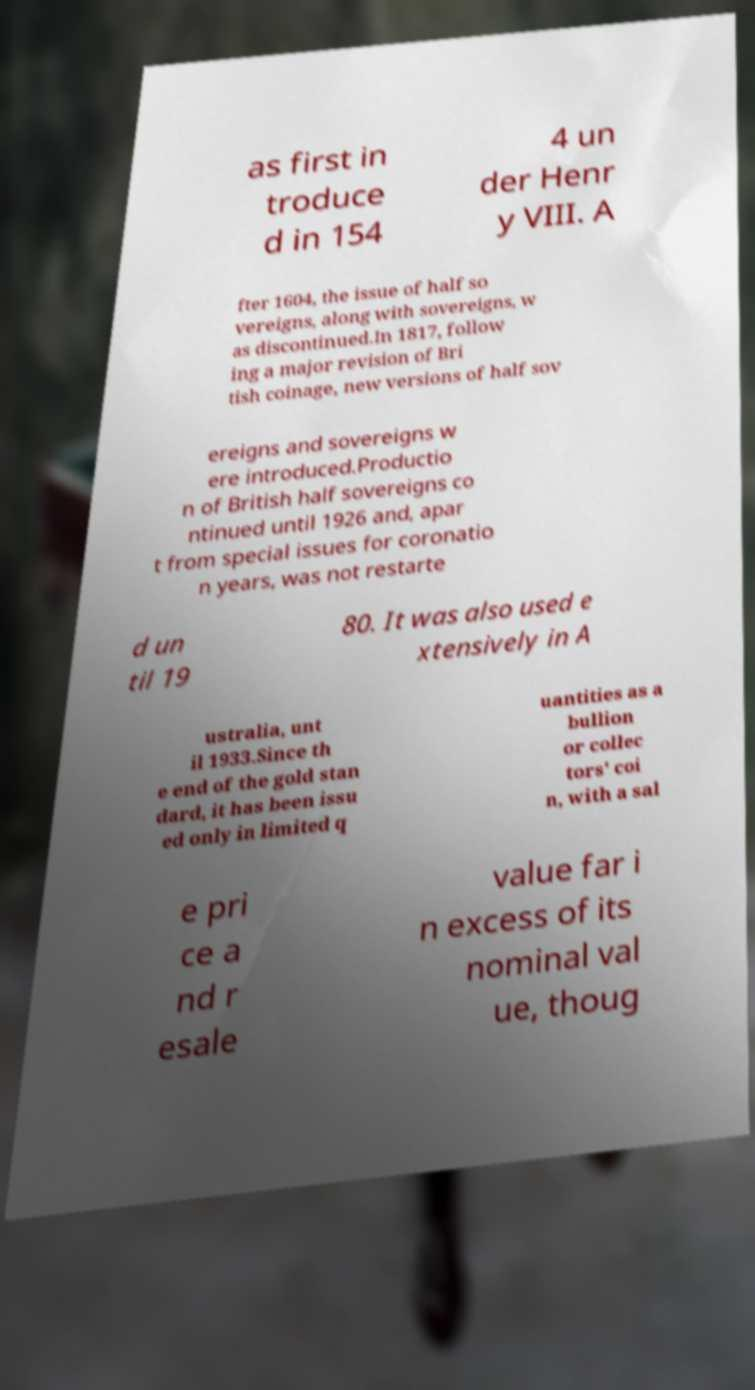Could you assist in decoding the text presented in this image and type it out clearly? as first in troduce d in 154 4 un der Henr y VIII. A fter 1604, the issue of half so vereigns, along with sovereigns, w as discontinued.In 1817, follow ing a major revision of Bri tish coinage, new versions of half sov ereigns and sovereigns w ere introduced.Productio n of British half sovereigns co ntinued until 1926 and, apar t from special issues for coronatio n years, was not restarte d un til 19 80. It was also used e xtensively in A ustralia, unt il 1933.Since th e end of the gold stan dard, it has been issu ed only in limited q uantities as a bullion or collec tors' coi n, with a sal e pri ce a nd r esale value far i n excess of its nominal val ue, thoug 